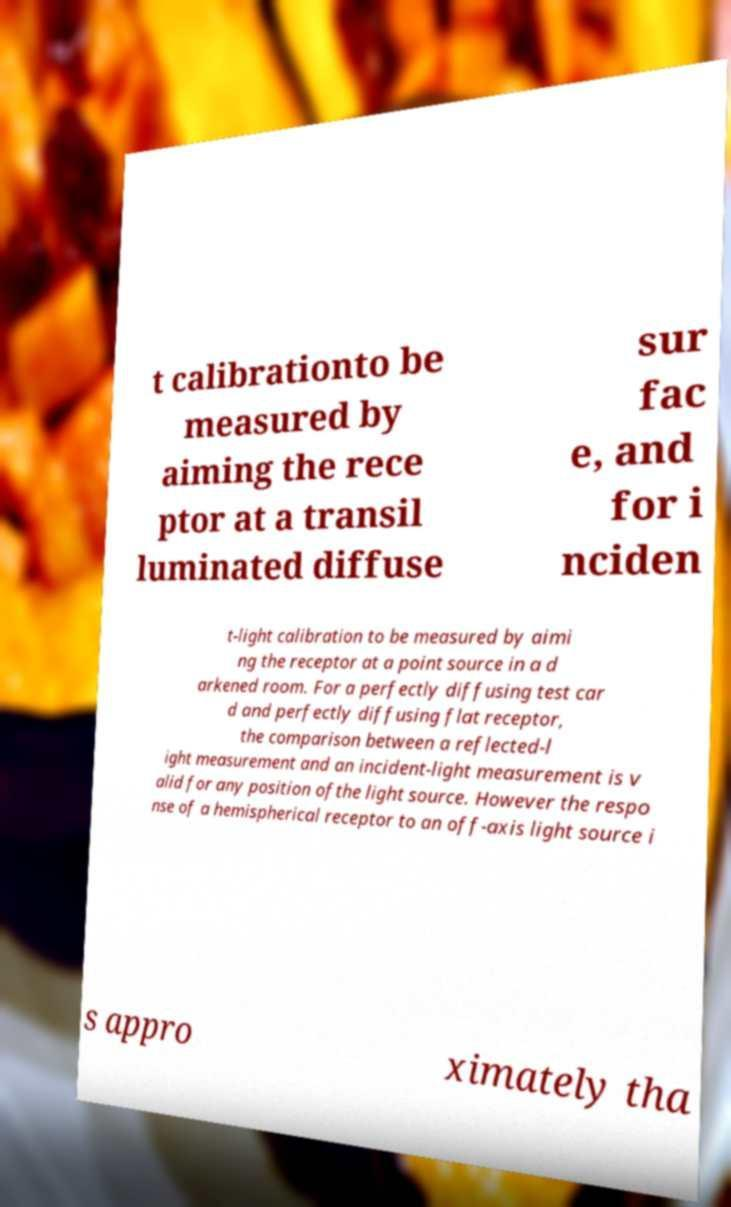There's text embedded in this image that I need extracted. Can you transcribe it verbatim? t calibrationto be measured by aiming the rece ptor at a transil luminated diffuse sur fac e, and for i nciden t-light calibration to be measured by aimi ng the receptor at a point source in a d arkened room. For a perfectly diffusing test car d and perfectly diffusing flat receptor, the comparison between a reflected-l ight measurement and an incident-light measurement is v alid for any position ofthe light source. However the respo nse of a hemispherical receptor to an off-axis light source i s appro ximately tha 